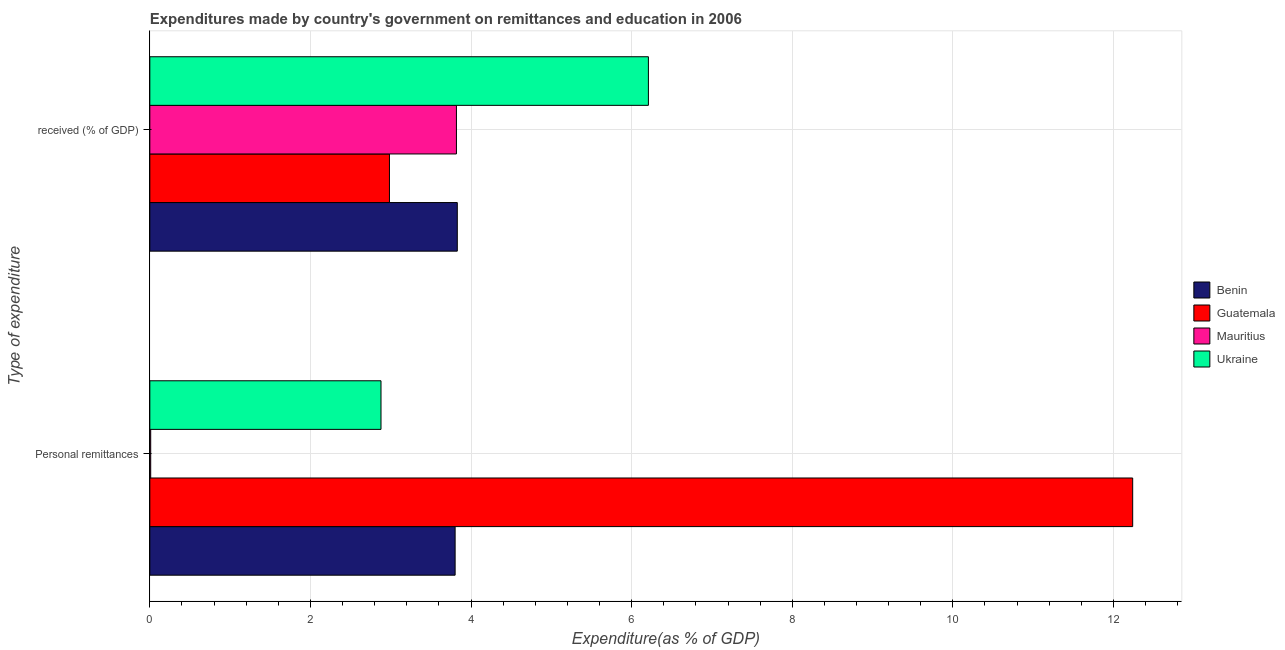How many different coloured bars are there?
Make the answer very short. 4. Are the number of bars per tick equal to the number of legend labels?
Ensure brevity in your answer.  Yes. Are the number of bars on each tick of the Y-axis equal?
Ensure brevity in your answer.  Yes. How many bars are there on the 2nd tick from the bottom?
Make the answer very short. 4. What is the label of the 1st group of bars from the top?
Offer a very short reply.  received (% of GDP). What is the expenditure in personal remittances in Guatemala?
Your answer should be compact. 12.24. Across all countries, what is the maximum expenditure in education?
Provide a short and direct response. 6.21. Across all countries, what is the minimum expenditure in personal remittances?
Make the answer very short. 0.01. In which country was the expenditure in education maximum?
Offer a terse response. Ukraine. In which country was the expenditure in education minimum?
Ensure brevity in your answer.  Guatemala. What is the total expenditure in education in the graph?
Your response must be concise. 16.84. What is the difference between the expenditure in personal remittances in Benin and that in Ukraine?
Your answer should be compact. 0.92. What is the difference between the expenditure in education in Mauritius and the expenditure in personal remittances in Benin?
Offer a very short reply. 0.02. What is the average expenditure in education per country?
Provide a succinct answer. 4.21. What is the difference between the expenditure in personal remittances and expenditure in education in Guatemala?
Provide a short and direct response. 9.26. What is the ratio of the expenditure in education in Guatemala to that in Mauritius?
Your answer should be very brief. 0.78. In how many countries, is the expenditure in education greater than the average expenditure in education taken over all countries?
Offer a terse response. 1. What does the 1st bar from the top in  received (% of GDP) represents?
Your answer should be compact. Ukraine. What does the 2nd bar from the bottom in  received (% of GDP) represents?
Keep it short and to the point. Guatemala. Are all the bars in the graph horizontal?
Ensure brevity in your answer.  Yes. What is the difference between two consecutive major ticks on the X-axis?
Offer a terse response. 2. Are the values on the major ticks of X-axis written in scientific E-notation?
Provide a succinct answer. No. Does the graph contain any zero values?
Your response must be concise. No. Does the graph contain grids?
Keep it short and to the point. Yes. Where does the legend appear in the graph?
Offer a very short reply. Center right. How are the legend labels stacked?
Provide a short and direct response. Vertical. What is the title of the graph?
Your response must be concise. Expenditures made by country's government on remittances and education in 2006. What is the label or title of the X-axis?
Make the answer very short. Expenditure(as % of GDP). What is the label or title of the Y-axis?
Your answer should be very brief. Type of expenditure. What is the Expenditure(as % of GDP) of Benin in Personal remittances?
Offer a very short reply. 3.8. What is the Expenditure(as % of GDP) in Guatemala in Personal remittances?
Offer a very short reply. 12.24. What is the Expenditure(as % of GDP) in Mauritius in Personal remittances?
Ensure brevity in your answer.  0.01. What is the Expenditure(as % of GDP) of Ukraine in Personal remittances?
Ensure brevity in your answer.  2.88. What is the Expenditure(as % of GDP) in Benin in  received (% of GDP)?
Your answer should be compact. 3.83. What is the Expenditure(as % of GDP) in Guatemala in  received (% of GDP)?
Keep it short and to the point. 2.98. What is the Expenditure(as % of GDP) in Mauritius in  received (% of GDP)?
Keep it short and to the point. 3.82. What is the Expenditure(as % of GDP) of Ukraine in  received (% of GDP)?
Your answer should be compact. 6.21. Across all Type of expenditure, what is the maximum Expenditure(as % of GDP) of Benin?
Ensure brevity in your answer.  3.83. Across all Type of expenditure, what is the maximum Expenditure(as % of GDP) in Guatemala?
Offer a very short reply. 12.24. Across all Type of expenditure, what is the maximum Expenditure(as % of GDP) in Mauritius?
Offer a very short reply. 3.82. Across all Type of expenditure, what is the maximum Expenditure(as % of GDP) of Ukraine?
Your answer should be compact. 6.21. Across all Type of expenditure, what is the minimum Expenditure(as % of GDP) of Benin?
Ensure brevity in your answer.  3.8. Across all Type of expenditure, what is the minimum Expenditure(as % of GDP) of Guatemala?
Give a very brief answer. 2.98. Across all Type of expenditure, what is the minimum Expenditure(as % of GDP) in Mauritius?
Give a very brief answer. 0.01. Across all Type of expenditure, what is the minimum Expenditure(as % of GDP) in Ukraine?
Ensure brevity in your answer.  2.88. What is the total Expenditure(as % of GDP) in Benin in the graph?
Offer a terse response. 7.63. What is the total Expenditure(as % of GDP) of Guatemala in the graph?
Provide a succinct answer. 15.22. What is the total Expenditure(as % of GDP) of Mauritius in the graph?
Offer a very short reply. 3.83. What is the total Expenditure(as % of GDP) of Ukraine in the graph?
Keep it short and to the point. 9.09. What is the difference between the Expenditure(as % of GDP) in Benin in Personal remittances and that in  received (% of GDP)?
Provide a succinct answer. -0.03. What is the difference between the Expenditure(as % of GDP) in Guatemala in Personal remittances and that in  received (% of GDP)?
Your answer should be compact. 9.26. What is the difference between the Expenditure(as % of GDP) of Mauritius in Personal remittances and that in  received (% of GDP)?
Keep it short and to the point. -3.81. What is the difference between the Expenditure(as % of GDP) in Ukraine in Personal remittances and that in  received (% of GDP)?
Ensure brevity in your answer.  -3.33. What is the difference between the Expenditure(as % of GDP) in Benin in Personal remittances and the Expenditure(as % of GDP) in Guatemala in  received (% of GDP)?
Ensure brevity in your answer.  0.82. What is the difference between the Expenditure(as % of GDP) of Benin in Personal remittances and the Expenditure(as % of GDP) of Mauritius in  received (% of GDP)?
Keep it short and to the point. -0.02. What is the difference between the Expenditure(as % of GDP) in Benin in Personal remittances and the Expenditure(as % of GDP) in Ukraine in  received (% of GDP)?
Provide a short and direct response. -2.41. What is the difference between the Expenditure(as % of GDP) of Guatemala in Personal remittances and the Expenditure(as % of GDP) of Mauritius in  received (% of GDP)?
Your response must be concise. 8.42. What is the difference between the Expenditure(as % of GDP) of Guatemala in Personal remittances and the Expenditure(as % of GDP) of Ukraine in  received (% of GDP)?
Offer a very short reply. 6.03. What is the difference between the Expenditure(as % of GDP) of Mauritius in Personal remittances and the Expenditure(as % of GDP) of Ukraine in  received (% of GDP)?
Give a very brief answer. -6.2. What is the average Expenditure(as % of GDP) in Benin per Type of expenditure?
Ensure brevity in your answer.  3.82. What is the average Expenditure(as % of GDP) of Guatemala per Type of expenditure?
Your response must be concise. 7.61. What is the average Expenditure(as % of GDP) in Mauritius per Type of expenditure?
Keep it short and to the point. 1.91. What is the average Expenditure(as % of GDP) of Ukraine per Type of expenditure?
Offer a very short reply. 4.54. What is the difference between the Expenditure(as % of GDP) in Benin and Expenditure(as % of GDP) in Guatemala in Personal remittances?
Offer a terse response. -8.44. What is the difference between the Expenditure(as % of GDP) of Benin and Expenditure(as % of GDP) of Mauritius in Personal remittances?
Offer a terse response. 3.79. What is the difference between the Expenditure(as % of GDP) in Benin and Expenditure(as % of GDP) in Ukraine in Personal remittances?
Offer a terse response. 0.92. What is the difference between the Expenditure(as % of GDP) of Guatemala and Expenditure(as % of GDP) of Mauritius in Personal remittances?
Ensure brevity in your answer.  12.23. What is the difference between the Expenditure(as % of GDP) in Guatemala and Expenditure(as % of GDP) in Ukraine in Personal remittances?
Your response must be concise. 9.36. What is the difference between the Expenditure(as % of GDP) in Mauritius and Expenditure(as % of GDP) in Ukraine in Personal remittances?
Offer a very short reply. -2.87. What is the difference between the Expenditure(as % of GDP) in Benin and Expenditure(as % of GDP) in Guatemala in  received (% of GDP)?
Provide a short and direct response. 0.84. What is the difference between the Expenditure(as % of GDP) of Benin and Expenditure(as % of GDP) of Mauritius in  received (% of GDP)?
Your answer should be very brief. 0.01. What is the difference between the Expenditure(as % of GDP) in Benin and Expenditure(as % of GDP) in Ukraine in  received (% of GDP)?
Offer a very short reply. -2.38. What is the difference between the Expenditure(as % of GDP) of Guatemala and Expenditure(as % of GDP) of Mauritius in  received (% of GDP)?
Keep it short and to the point. -0.83. What is the difference between the Expenditure(as % of GDP) in Guatemala and Expenditure(as % of GDP) in Ukraine in  received (% of GDP)?
Your answer should be very brief. -3.22. What is the difference between the Expenditure(as % of GDP) in Mauritius and Expenditure(as % of GDP) in Ukraine in  received (% of GDP)?
Your response must be concise. -2.39. What is the ratio of the Expenditure(as % of GDP) of Guatemala in Personal remittances to that in  received (% of GDP)?
Your answer should be compact. 4.1. What is the ratio of the Expenditure(as % of GDP) in Mauritius in Personal remittances to that in  received (% of GDP)?
Ensure brevity in your answer.  0. What is the ratio of the Expenditure(as % of GDP) of Ukraine in Personal remittances to that in  received (% of GDP)?
Ensure brevity in your answer.  0.46. What is the difference between the highest and the second highest Expenditure(as % of GDP) of Benin?
Give a very brief answer. 0.03. What is the difference between the highest and the second highest Expenditure(as % of GDP) in Guatemala?
Offer a very short reply. 9.26. What is the difference between the highest and the second highest Expenditure(as % of GDP) in Mauritius?
Your answer should be very brief. 3.81. What is the difference between the highest and the second highest Expenditure(as % of GDP) in Ukraine?
Provide a short and direct response. 3.33. What is the difference between the highest and the lowest Expenditure(as % of GDP) of Benin?
Provide a short and direct response. 0.03. What is the difference between the highest and the lowest Expenditure(as % of GDP) in Guatemala?
Offer a terse response. 9.26. What is the difference between the highest and the lowest Expenditure(as % of GDP) of Mauritius?
Offer a very short reply. 3.81. What is the difference between the highest and the lowest Expenditure(as % of GDP) of Ukraine?
Keep it short and to the point. 3.33. 